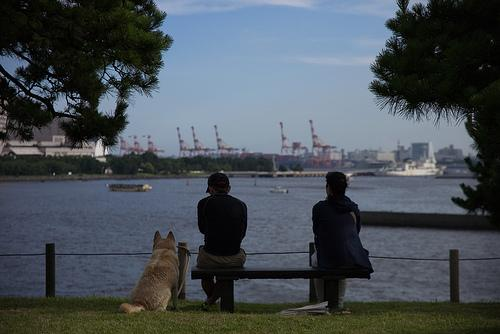List the main subjects in the image and their corresponding verbs. White clouds (floating), boats (docked), couple (sitting), man (wearing baseball cap), person (wearing light-blue jacket), and dog (tied to a pole). Enumerate the most striking elements in the image and any activities they are performing. 1. White clouds in blue sky, 2. White boats in water, 3. Couple on a bench, 4. Man in baseball cap, 5. Person in light-blue jacket, 6. Leashed dog. Describe the key characteristics and features in the image with no specific order. Cloudy blue sky, white boats on water, two people on a bench, man in baseball cap, person in light blue jacket, and a leashed dog. State the important elements found within the image and any event occurring. White clouds in sky, white boats on water, sitting couple, man in baseball cap, person in light blue jacket, and leashed dog observing. Give a brief overview of the image's main components and actions happening. A couple sits on a bench near water with boats, while a leashed dog looks on, and white clouds fill the blue sky above. Sum up the image's key elements and activities in a single phrase. Sky, boats, bench-sitters, and a nosey leashed dog enjoying a day by the water. What are the main objects and actions taking place in the image? White clouds, boats on the water, couple on bench, man wearing baseball cap, light-blue jacket person, and a dog with a leash. Highlight notable objects, colors, and scenes in the image. Cloud-filled blue sky, white boats on water, sitting couple near dog, and individuals in baseball cap and light-blue jacket. Propose a headline for the image based on its key visuals and events. "A Relaxing Day by the Water: Boats, Clouds, and a Leashed Dog." Mention the primary elements in the image and their locations. White clouds in blue sky, white boats on water under trees, man wearing baseball cap, light-blue jacket person, two people sitting on a bench, and a dog with leash tied to pole. 